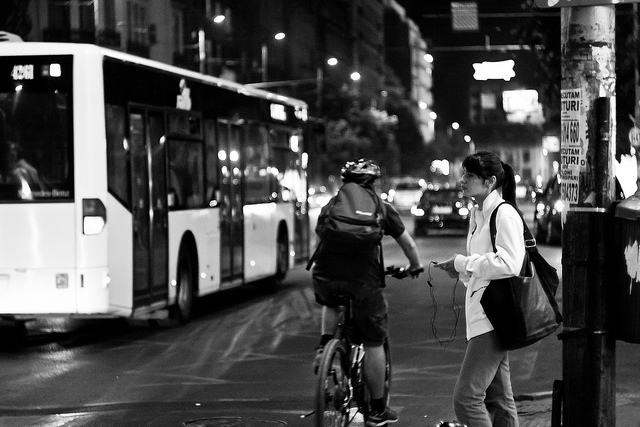Identify and read out the text in this image. TURI TURI 